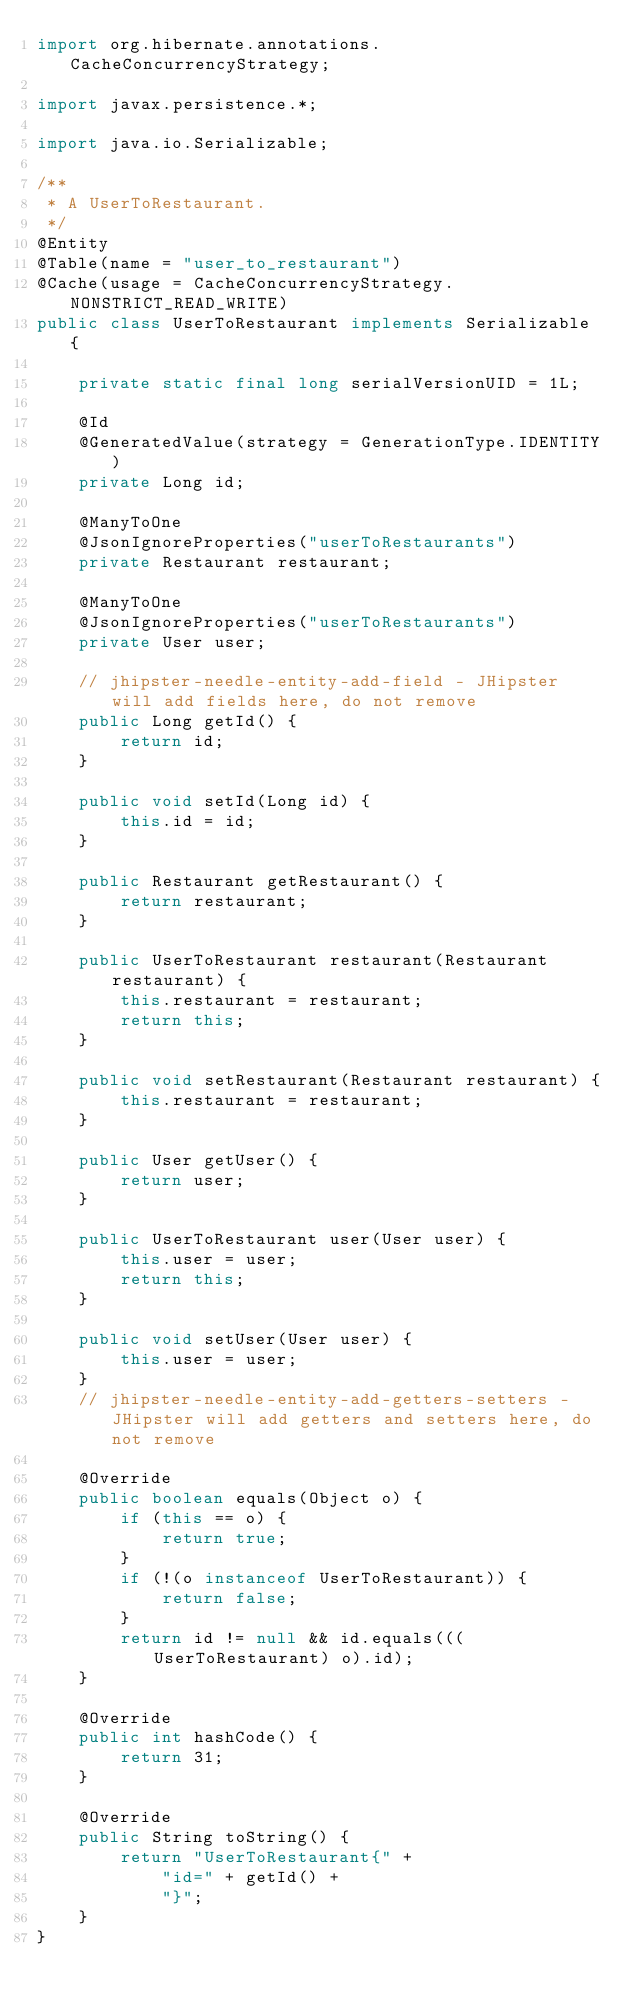Convert code to text. <code><loc_0><loc_0><loc_500><loc_500><_Java_>import org.hibernate.annotations.CacheConcurrencyStrategy;

import javax.persistence.*;

import java.io.Serializable;

/**
 * A UserToRestaurant.
 */
@Entity
@Table(name = "user_to_restaurant")
@Cache(usage = CacheConcurrencyStrategy.NONSTRICT_READ_WRITE)
public class UserToRestaurant implements Serializable {

    private static final long serialVersionUID = 1L;

    @Id
    @GeneratedValue(strategy = GenerationType.IDENTITY)
    private Long id;

    @ManyToOne
    @JsonIgnoreProperties("userToRestaurants")
    private Restaurant restaurant;

    @ManyToOne
    @JsonIgnoreProperties("userToRestaurants")
    private User user;

    // jhipster-needle-entity-add-field - JHipster will add fields here, do not remove
    public Long getId() {
        return id;
    }

    public void setId(Long id) {
        this.id = id;
    }

    public Restaurant getRestaurant() {
        return restaurant;
    }

    public UserToRestaurant restaurant(Restaurant restaurant) {
        this.restaurant = restaurant;
        return this;
    }

    public void setRestaurant(Restaurant restaurant) {
        this.restaurant = restaurant;
    }

    public User getUser() {
        return user;
    }

    public UserToRestaurant user(User user) {
        this.user = user;
        return this;
    }

    public void setUser(User user) {
        this.user = user;
    }
    // jhipster-needle-entity-add-getters-setters - JHipster will add getters and setters here, do not remove

    @Override
    public boolean equals(Object o) {
        if (this == o) {
            return true;
        }
        if (!(o instanceof UserToRestaurant)) {
            return false;
        }
        return id != null && id.equals(((UserToRestaurant) o).id);
    }

    @Override
    public int hashCode() {
        return 31;
    }

    @Override
    public String toString() {
        return "UserToRestaurant{" +
            "id=" + getId() +
            "}";
    }
}
</code> 